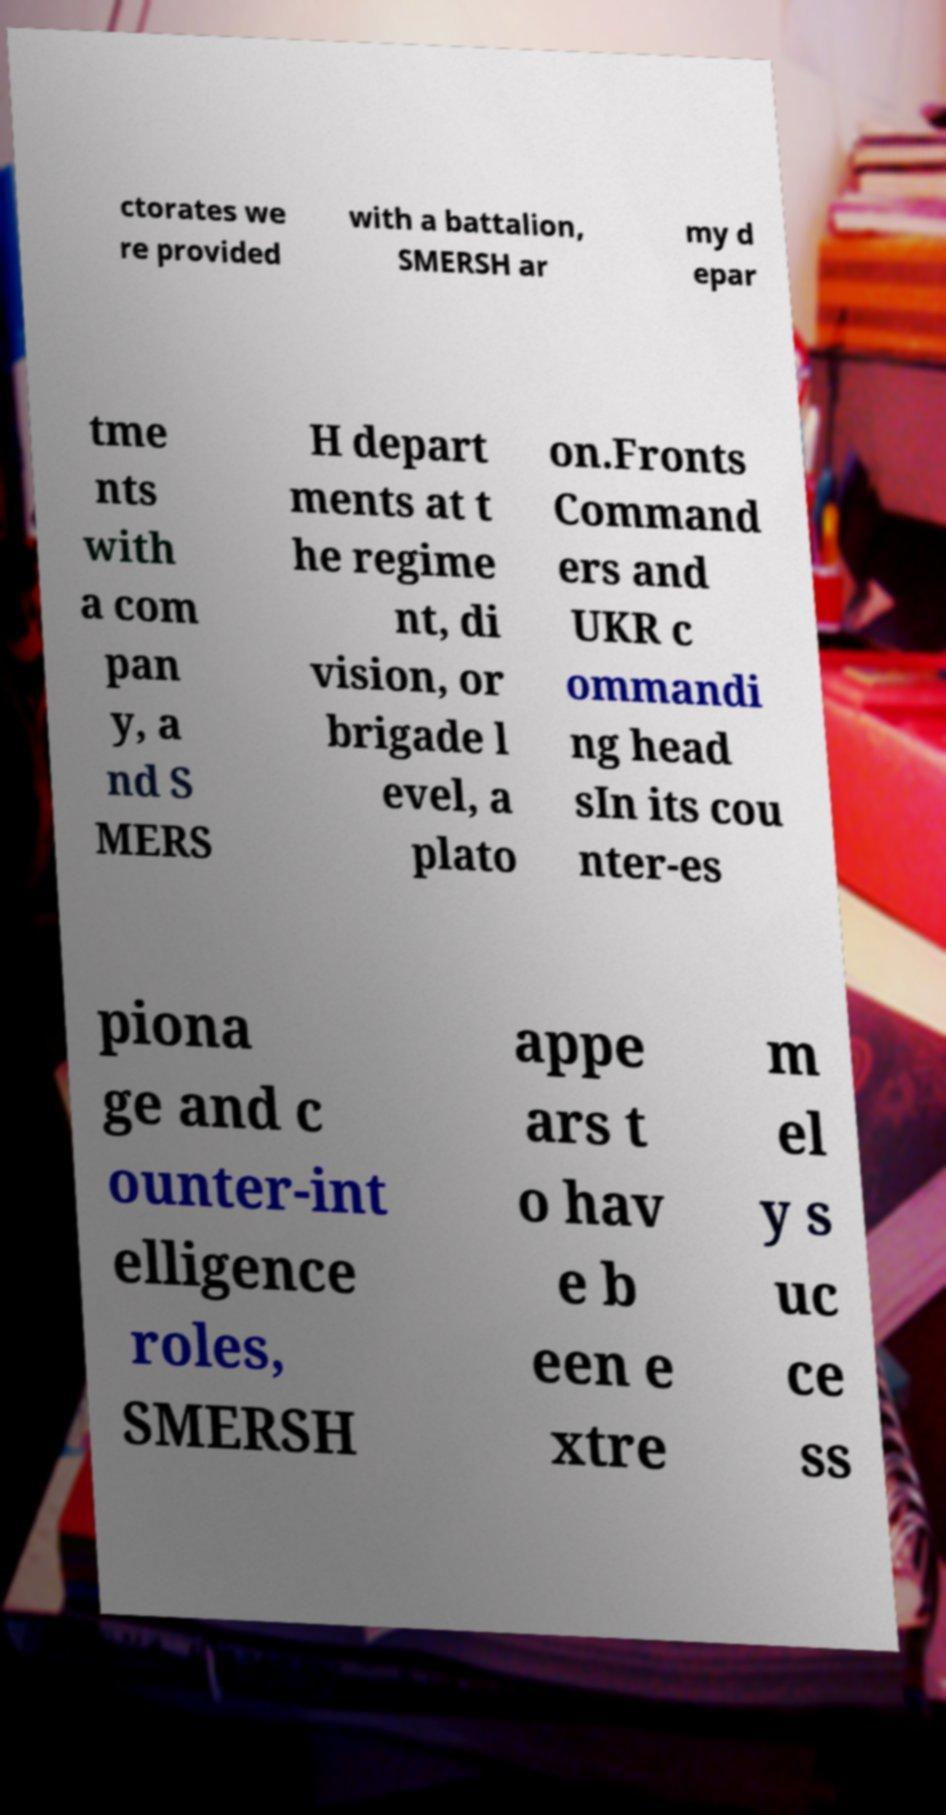Could you assist in decoding the text presented in this image and type it out clearly? ctorates we re provided with a battalion, SMERSH ar my d epar tme nts with a com pan y, a nd S MERS H depart ments at t he regime nt, di vision, or brigade l evel, a plato on.Fronts Command ers and UKR c ommandi ng head sIn its cou nter-es piona ge and c ounter-int elligence roles, SMERSH appe ars t o hav e b een e xtre m el y s uc ce ss 